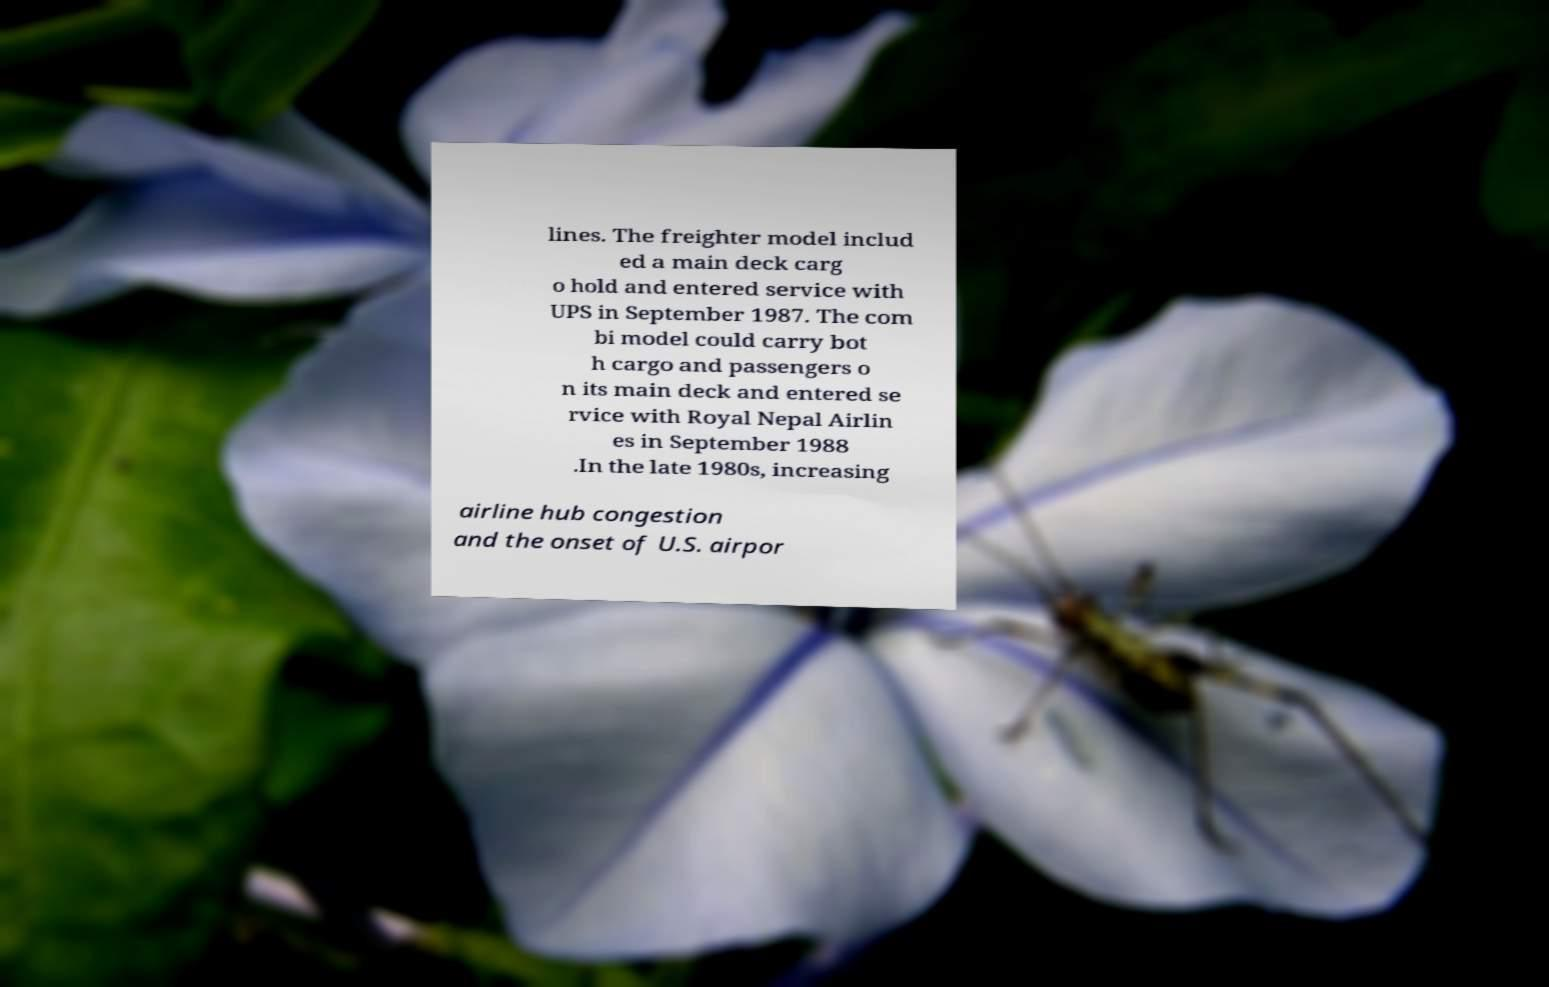What messages or text are displayed in this image? I need them in a readable, typed format. lines. The freighter model includ ed a main deck carg o hold and entered service with UPS in September 1987. The com bi model could carry bot h cargo and passengers o n its main deck and entered se rvice with Royal Nepal Airlin es in September 1988 .In the late 1980s, increasing airline hub congestion and the onset of U.S. airpor 